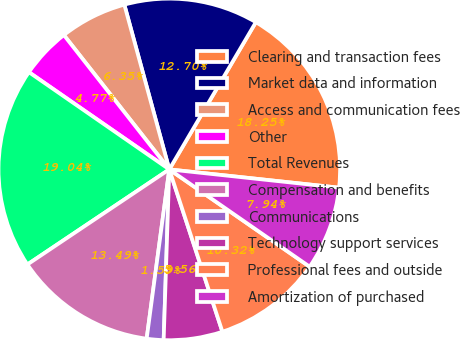Convert chart. <chart><loc_0><loc_0><loc_500><loc_500><pie_chart><fcel>Clearing and transaction fees<fcel>Market data and information<fcel>Access and communication fees<fcel>Other<fcel>Total Revenues<fcel>Compensation and benefits<fcel>Communications<fcel>Technology support services<fcel>Professional fees and outside<fcel>Amortization of purchased<nl><fcel>18.25%<fcel>12.7%<fcel>6.35%<fcel>4.77%<fcel>19.04%<fcel>13.49%<fcel>1.59%<fcel>5.56%<fcel>10.32%<fcel>7.94%<nl></chart> 